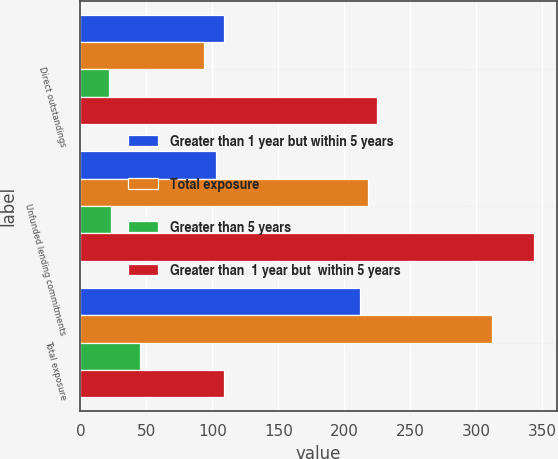<chart> <loc_0><loc_0><loc_500><loc_500><stacked_bar_chart><ecel><fcel>Direct outstandings<fcel>Unfunded lending commitments<fcel>Total exposure<nl><fcel>Greater than 1 year but within 5 years<fcel>109<fcel>103<fcel>212<nl><fcel>Total exposure<fcel>94<fcel>218<fcel>312<nl><fcel>Greater than 5 years<fcel>22<fcel>23<fcel>45<nl><fcel>Greater than  1 year but  within 5 years<fcel>225<fcel>344<fcel>109<nl></chart> 